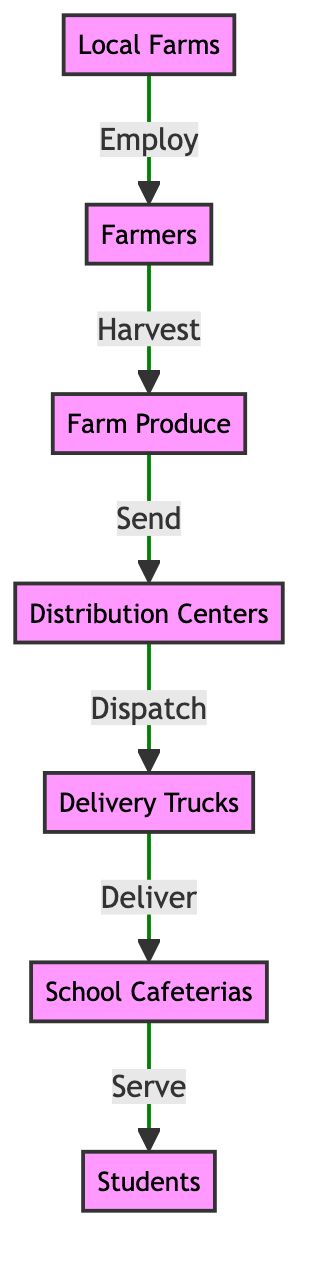What is the first node in the food chain? The first node represents the starting point of the food chain, which is Local Farms.
Answer: Local Farms How many nodes are present in this diagram? By counting each unique entity involved in the food chain, we find there are 7 nodes: Local Farms, Farmers, Farm Produce, Distribution Centers, Delivery Trucks, School Cafeterias, and Students.
Answer: 7 What is the last node in the food chain? The last node indicates the end recipient in the food chain, which is Students.
Answer: Students What is the role of Farmers in the food chain? Farmers are represented as the second node, indicating that they work directly under Local Farms and are responsible for harvesting the farm produce.
Answer: Harvest How many edges connect Local Farms to Farmers? An edge represents a relationship between two nodes, and there is one direct edge connecting Local Farms to Farmers, signifying the employment relationship.
Answer: 1 What do Delivery Trucks do in the food chain? Delivery Trucks are responsible for transporting the farm produce from Distribution Centers to School Cafeterias, as depicted in the diagram.
Answer: Deliver Which node receives produce from Distribution Centers? The School Cafeterias receive the farm produce dispatched from Distribution Centers, as shown in the flow of the diagram.
Answer: School Cafeterias How do Farmers interact with Local Farms? Farmers work at Local Farms, which is indicated by the connection labeled 'Employ', showing the employment relationship.
Answer: Employ What is the role of the Distribution Centers? Distribution Centers serve as a point where farm produce is sent, and they prepare for dispatching to the Delivery Trucks.
Answer: Send 